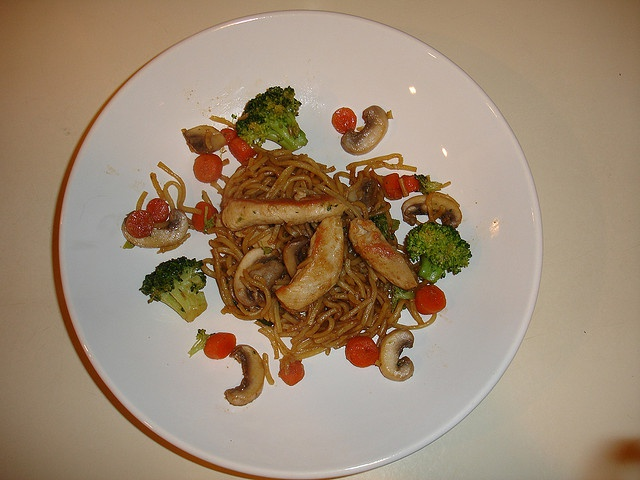Describe the objects in this image and their specific colors. I can see dining table in darkgray, tan, gray, and maroon tones, broccoli in maroon, olive, black, and darkgray tones, broccoli in maroon, darkgreen, black, and darkgray tones, broccoli in maroon, black, and olive tones, and carrot in maroon, brown, and lightgray tones in this image. 